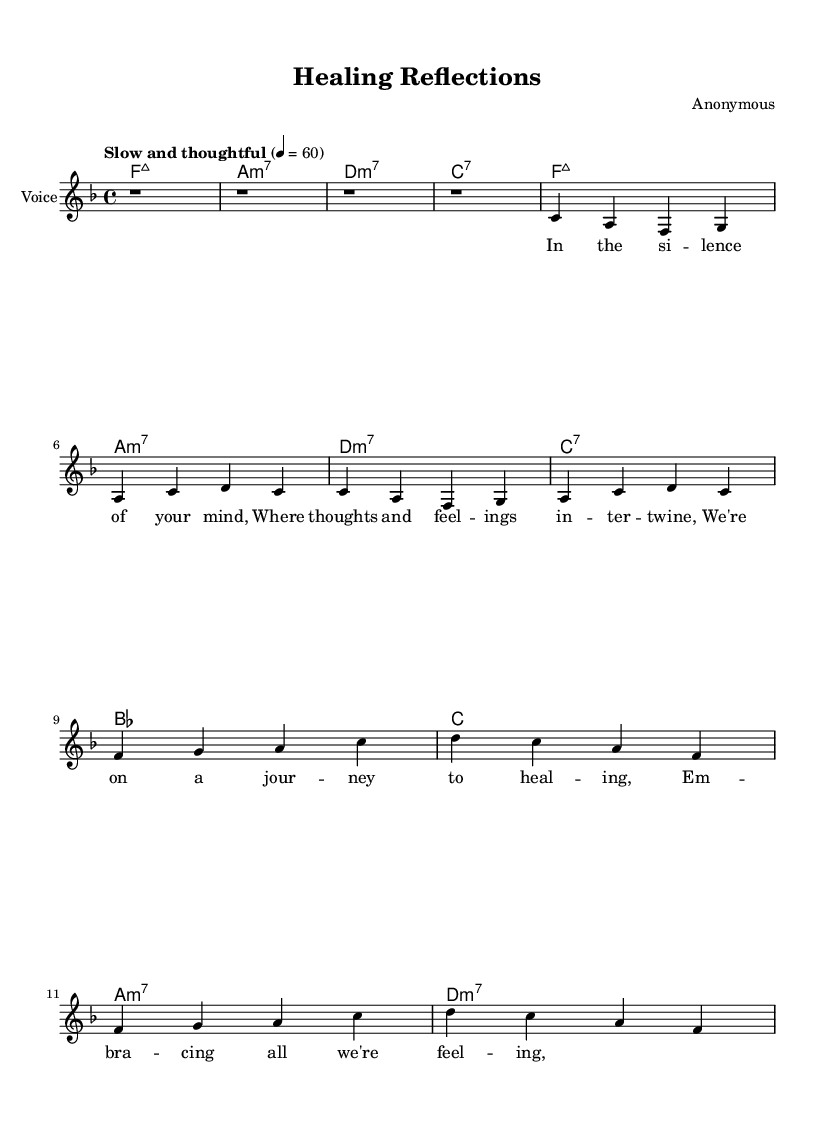What is the key signature of this music? The key signature is F major, which has one flat (B♭). This can be identified by looking at the beginning of the sheet music where the key signature is indicated.
Answer: F major What is the time signature of this music? The time signature is 4/4, which is visible at the beginning of the sheet music. This indicates there are four beats in each measure and the quarter note receives one beat.
Answer: 4/4 What is the tempo marking for this piece? The tempo marking is "Slow and thoughtful," which is explicitly stated in the tempo section at the beginning of the music.
Answer: Slow and thoughtful How many measures are in the chorus section? The chorus section has four measures, as indicated by the layout and grouping of the notes in that part of the sheet music.
Answer: Four What is the primary emotional theme addressed in the lyrics? The primary emotional theme is healing, as reflected in the lyrics that emphasize a journey to healing and embracing feelings.
Answer: Healing What type of chords are used during the intro? The chords used during the intro are major seventh chords, as indicated by the chord symbols provided for that section.
Answer: Major seventh What is the overall structure of the piece? The overall structure consists of an intro, followed by verses and a chorus, which is typical in many soul music compositions to address emotional and reflective themes.
Answer: Intro, verses, chorus 